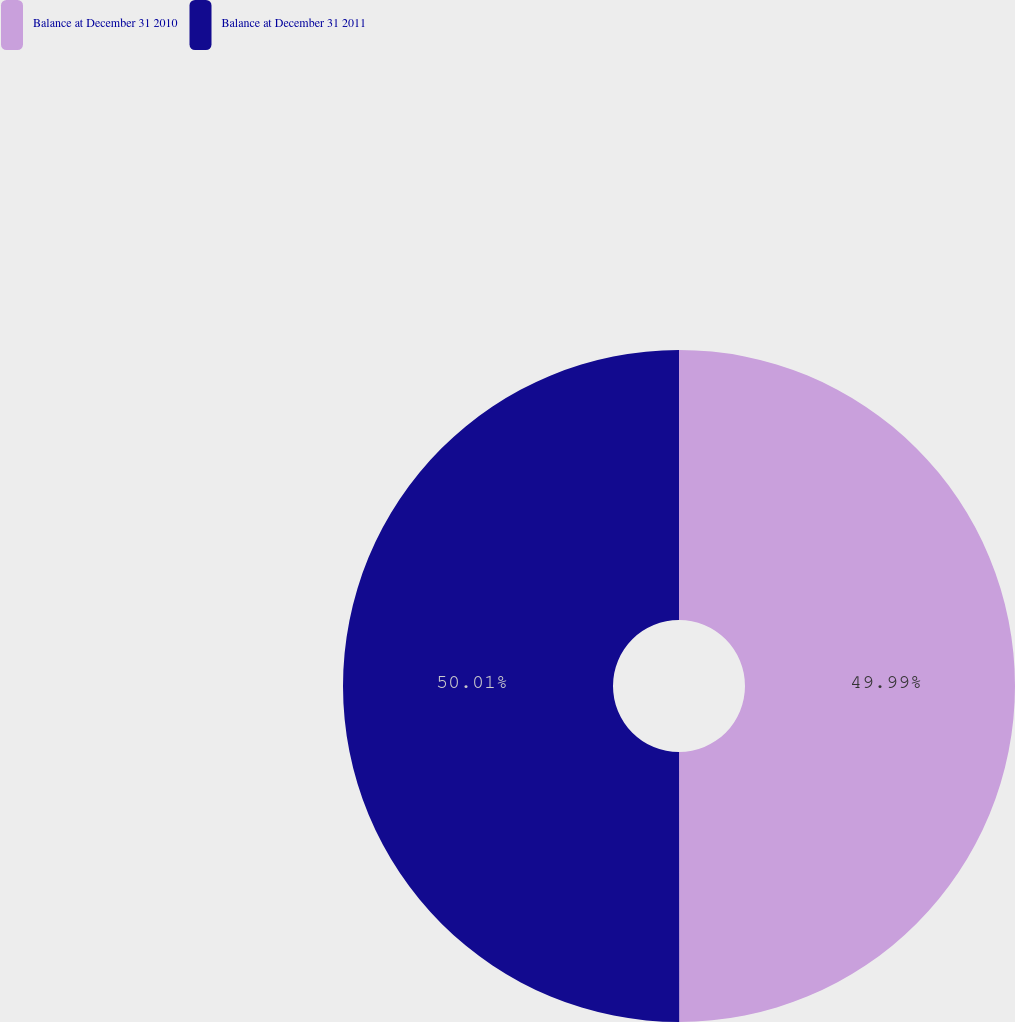<chart> <loc_0><loc_0><loc_500><loc_500><pie_chart><fcel>Balance at December 31 2010<fcel>Balance at December 31 2011<nl><fcel>49.99%<fcel>50.01%<nl></chart> 